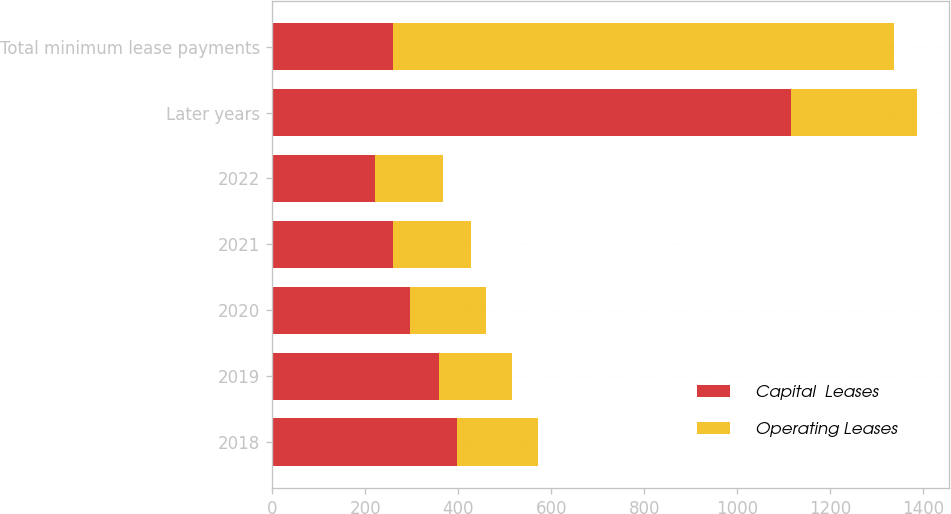Convert chart. <chart><loc_0><loc_0><loc_500><loc_500><stacked_bar_chart><ecel><fcel>2018<fcel>2019<fcel>2020<fcel>2021<fcel>2022<fcel>Later years<fcel>Total minimum lease payments<nl><fcel>Capital  Leases<fcel>398<fcel>359<fcel>297<fcel>259<fcel>221<fcel>1115<fcel>259<nl><fcel>Operating Leases<fcel>173<fcel>156<fcel>164<fcel>168<fcel>147<fcel>271<fcel>1079<nl></chart> 